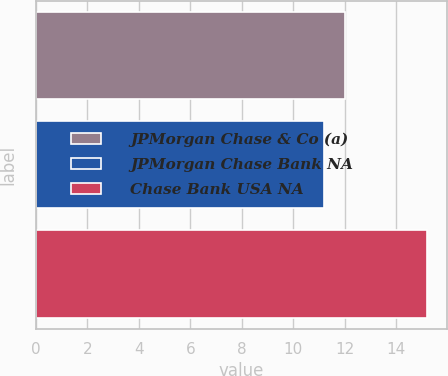Convert chart. <chart><loc_0><loc_0><loc_500><loc_500><bar_chart><fcel>JPMorgan Chase & Co (a)<fcel>JPMorgan Chase Bank NA<fcel>Chase Bank USA NA<nl><fcel>12<fcel>11.2<fcel>15.2<nl></chart> 